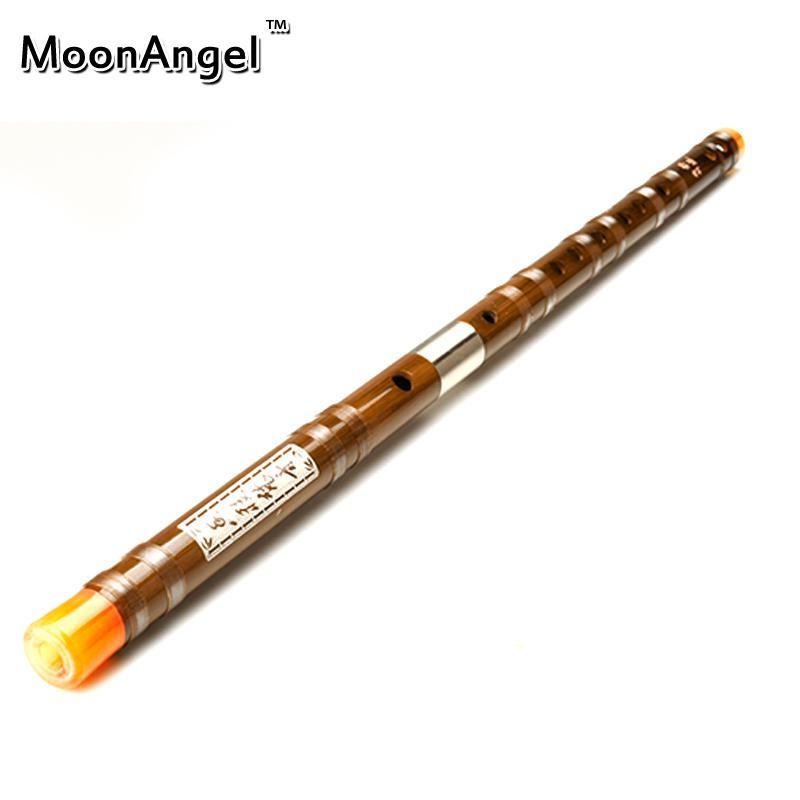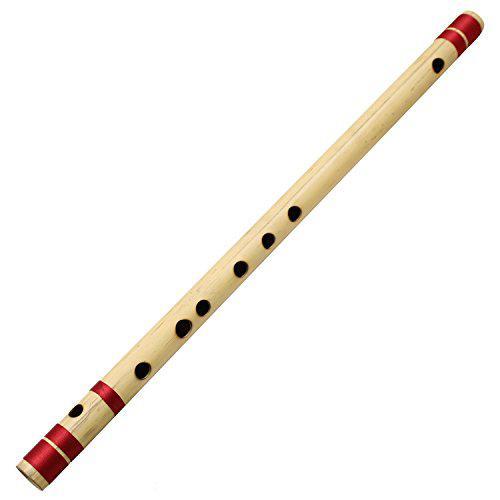The first image is the image on the left, the second image is the image on the right. Analyze the images presented: Is the assertion "A red tassel is connected to a straight flute." valid? Answer yes or no. No. The first image is the image on the left, the second image is the image on the right. Assess this claim about the two images: "One image shows a diagonally displayed, perforated stick-shaped instrument with a red tassel at its lower end, and the other image shows a similar gold and black instrument with no tassel.". Correct or not? Answer yes or no. No. 